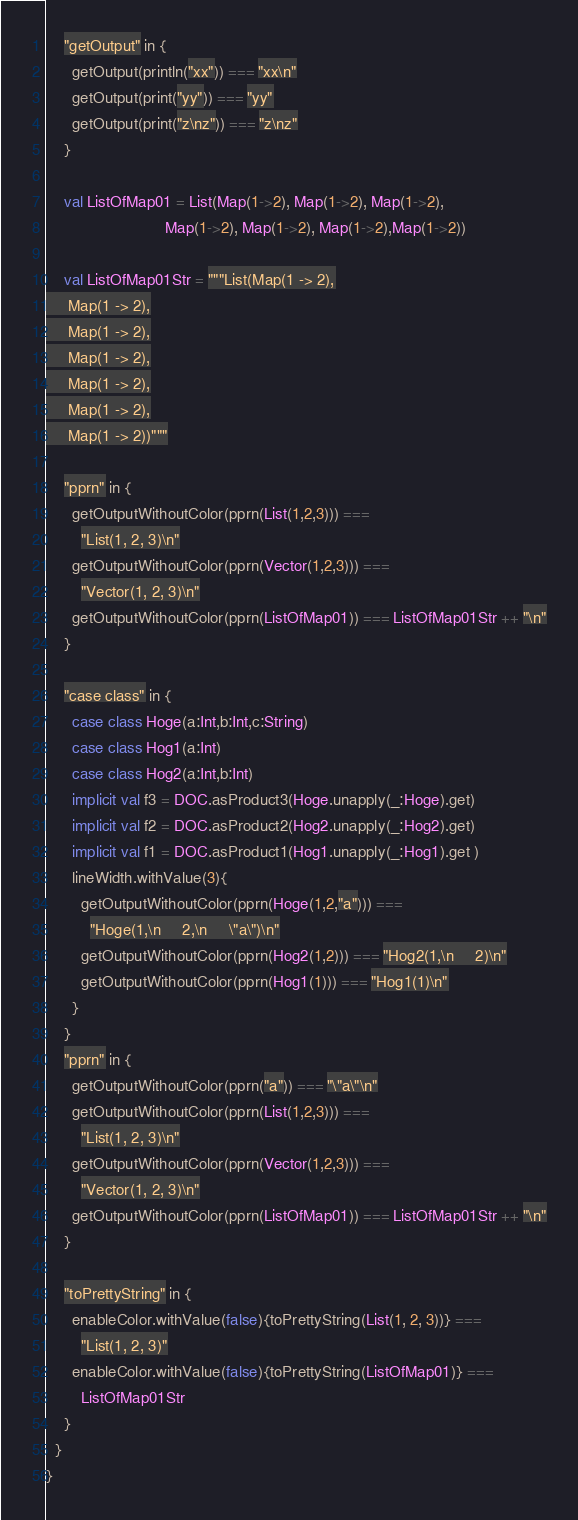Convert code to text. <code><loc_0><loc_0><loc_500><loc_500><_Scala_>	"getOutput" in {
	  getOutput(println("xx")) === "xx\n"
	  getOutput(print("yy")) === "yy"
	  getOutput(print("z\nz")) === "z\nz"
	}

	val ListOfMap01 = List(Map(1->2), Map(1->2), Map(1->2),
						   Map(1->2), Map(1->2), Map(1->2),Map(1->2))

	val ListOfMap01Str = """List(Map(1 -> 2),
     Map(1 -> 2),
     Map(1 -> 2),
     Map(1 -> 2),
     Map(1 -> 2),
     Map(1 -> 2),
     Map(1 -> 2))"""

    "pprn" in {
	  getOutputWithoutColor(pprn(List(1,2,3))) ===
		"List(1, 2, 3)\n"
	  getOutputWithoutColor(pprn(Vector(1,2,3))) ===
		"Vector(1, 2, 3)\n"
	  getOutputWithoutColor(pprn(ListOfMap01)) === ListOfMap01Str ++ "\n"
	}

    "case class" in {
      case class Hoge(a:Int,b:Int,c:String)
      case class Hog1(a:Int)
      case class Hog2(a:Int,b:Int)
      implicit val f3 = DOC.asProduct3(Hoge.unapply(_:Hoge).get)
      implicit val f2 = DOC.asProduct2(Hog2.unapply(_:Hog2).get)
      implicit val f1 = DOC.asProduct1(Hog1.unapply(_:Hog1).get )
      lineWidth.withValue(3){
        getOutputWithoutColor(pprn(Hoge(1,2,"a"))) ===
          "Hoge(1,\n     2,\n     \"a\")\n"
        getOutputWithoutColor(pprn(Hog2(1,2))) === "Hog2(1,\n     2)\n"
        getOutputWithoutColor(pprn(Hog1(1))) === "Hog1(1)\n"
      }
    }
    "pprn" in {
      getOutputWithoutColor(pprn("a")) === "\"a\"\n"
	  getOutputWithoutColor(pprn(List(1,2,3))) ===
		"List(1, 2, 3)\n"
	  getOutputWithoutColor(pprn(Vector(1,2,3))) ===
		"Vector(1, 2, 3)\n"
	  getOutputWithoutColor(pprn(ListOfMap01)) === ListOfMap01Str ++ "\n"
	}

    "toPrettyString" in {
	  enableColor.withValue(false){toPrettyString(List(1, 2, 3))} === 
		"List(1, 2, 3)"
	  enableColor.withValue(false){toPrettyString(ListOfMap01)} === 
		ListOfMap01Str
	}
  }
}
</code> 